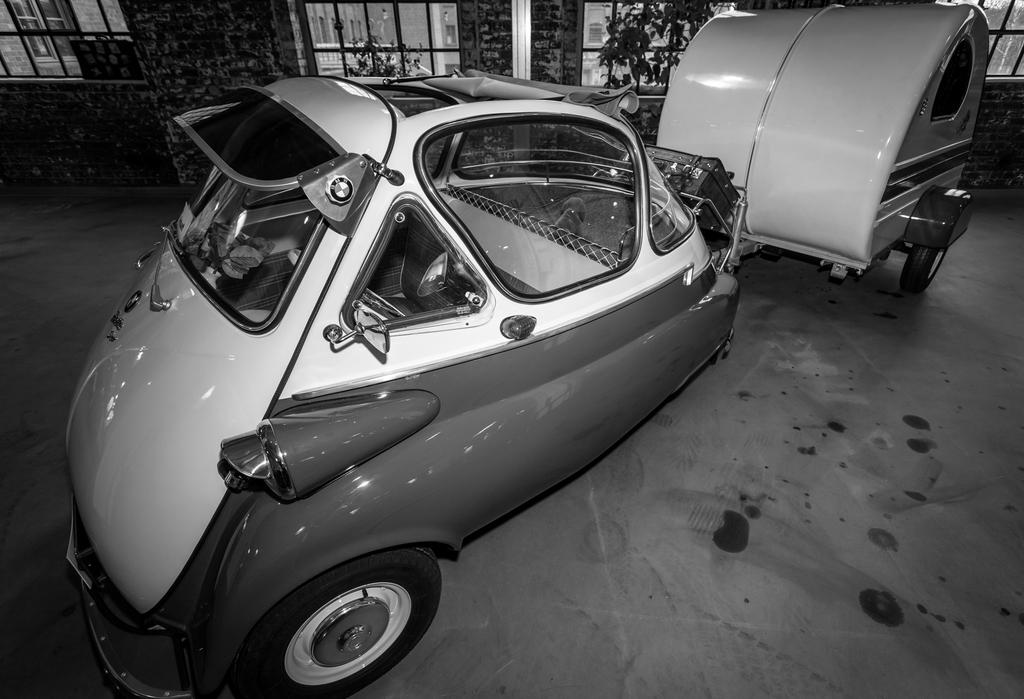What type of vehicle is in the image? There is a car-like vehicle in the image. What is the structure behind the car? There is a building with glass windows in the image. How is the building positioned in relation to the car? The building is behind the car. What type of vegetation is visible in the image? There is a plant visible in the image. What type of education can be seen being provided in the image? There is no indication of education being provided in the image. How many trees are visible in the image? There is no mention of trees in the image; only a plant is mentioned. 